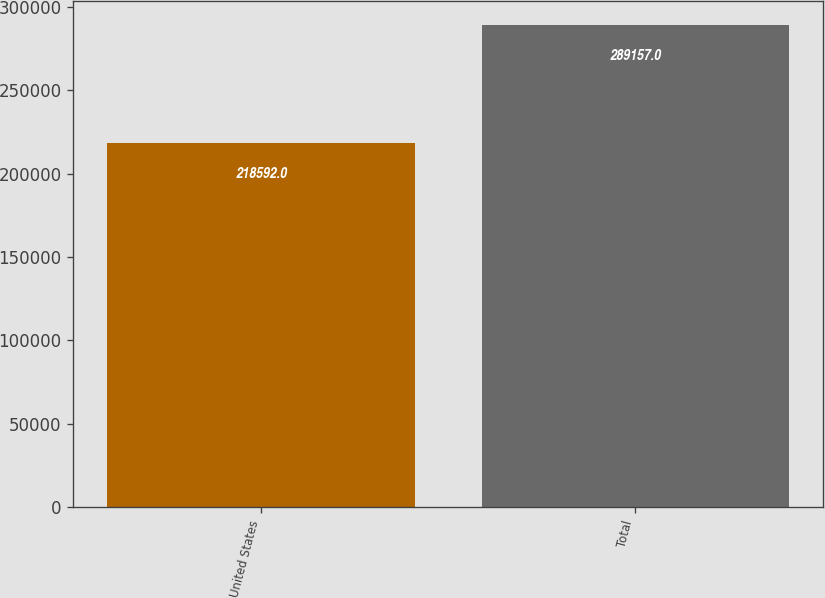<chart> <loc_0><loc_0><loc_500><loc_500><bar_chart><fcel>United States<fcel>Total<nl><fcel>218592<fcel>289157<nl></chart> 